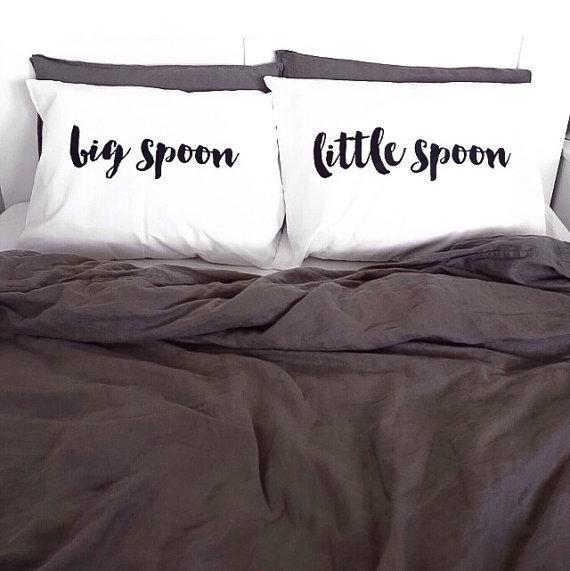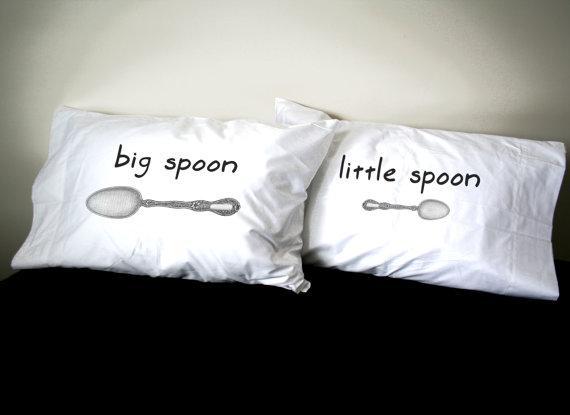The first image is the image on the left, the second image is the image on the right. Considering the images on both sides, is "A pair of pillows are printed with spoon shapes below lettering." valid? Answer yes or no. Yes. The first image is the image on the left, the second image is the image on the right. Given the left and right images, does the statement "All big spoons are to the left." hold true? Answer yes or no. Yes. 